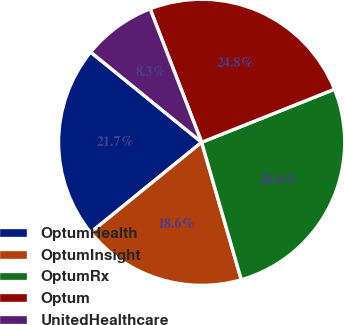Convert chart to OTSL. <chart><loc_0><loc_0><loc_500><loc_500><pie_chart><fcel>OptumHealth<fcel>OptumInsight<fcel>OptumRx<fcel>Optum<fcel>UnitedHealthcare<nl><fcel>21.72%<fcel>18.61%<fcel>26.58%<fcel>24.82%<fcel>8.27%<nl></chart> 